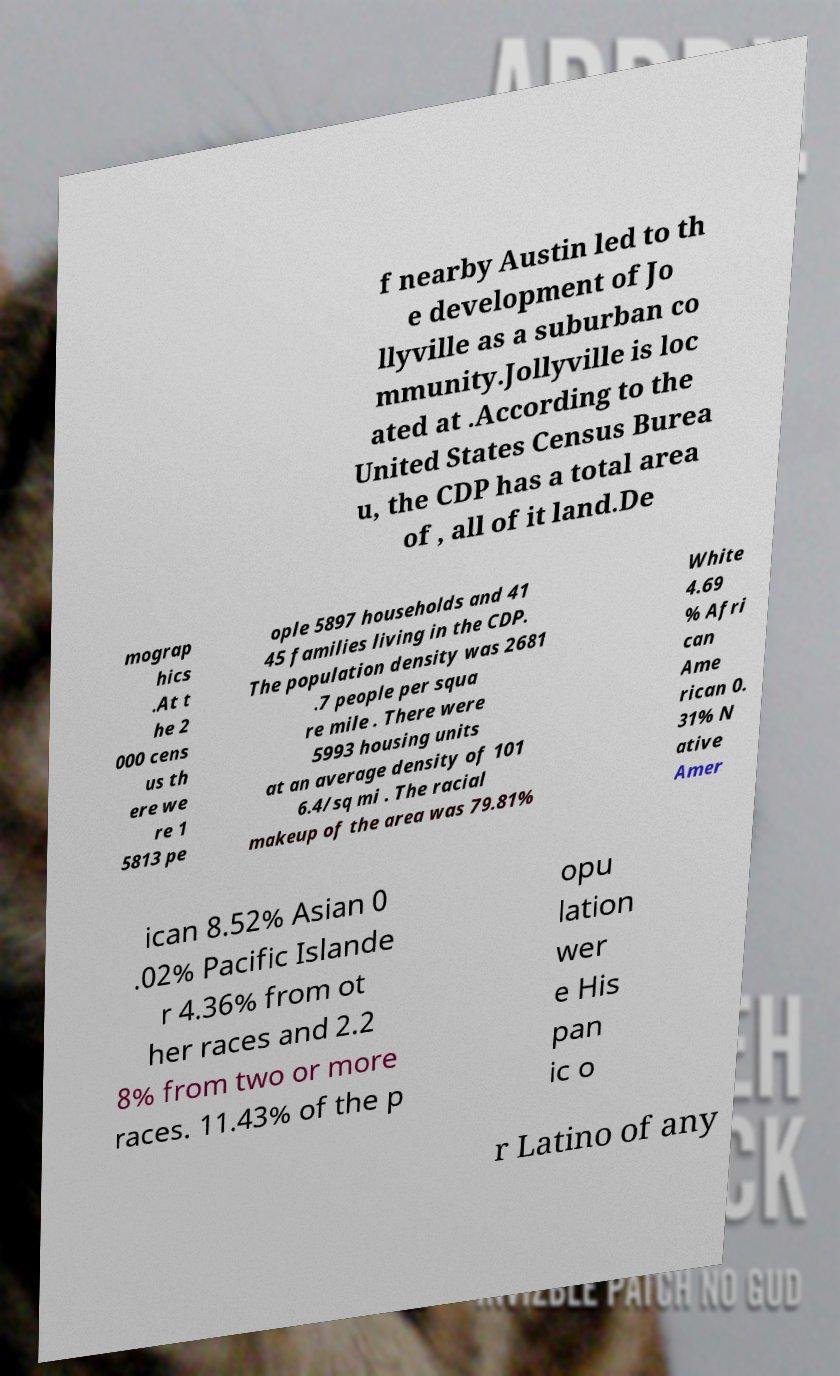Please identify and transcribe the text found in this image. f nearby Austin led to th e development of Jo llyville as a suburban co mmunity.Jollyville is loc ated at .According to the United States Census Burea u, the CDP has a total area of , all of it land.De mograp hics .At t he 2 000 cens us th ere we re 1 5813 pe ople 5897 households and 41 45 families living in the CDP. The population density was 2681 .7 people per squa re mile . There were 5993 housing units at an average density of 101 6.4/sq mi . The racial makeup of the area was 79.81% White 4.69 % Afri can Ame rican 0. 31% N ative Amer ican 8.52% Asian 0 .02% Pacific Islande r 4.36% from ot her races and 2.2 8% from two or more races. 11.43% of the p opu lation wer e His pan ic o r Latino of any 